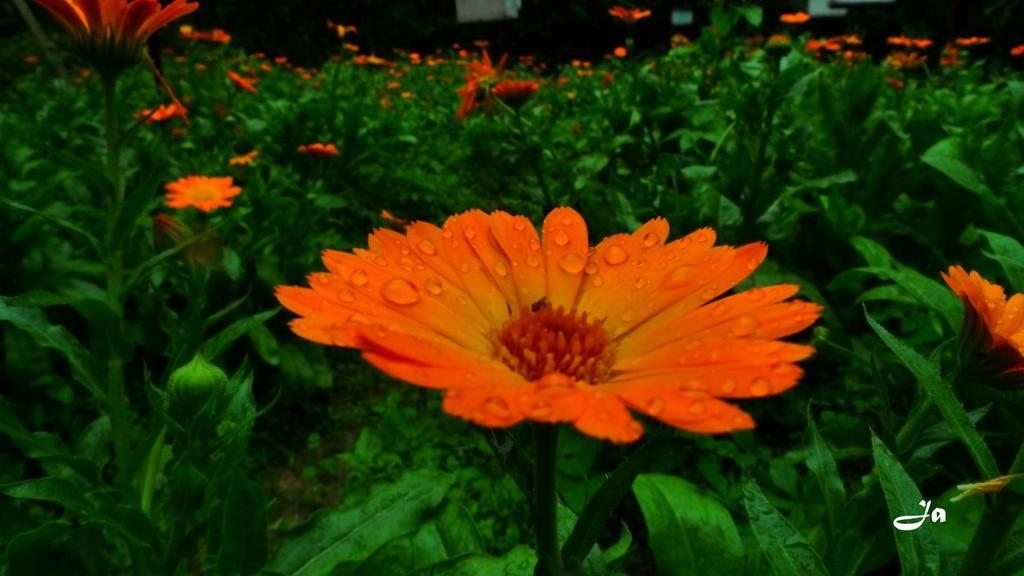Could you give a brief overview of what you see in this image? In this image I can see many flowers to the plants. These flowers are in orange color and the plants are in green color. 